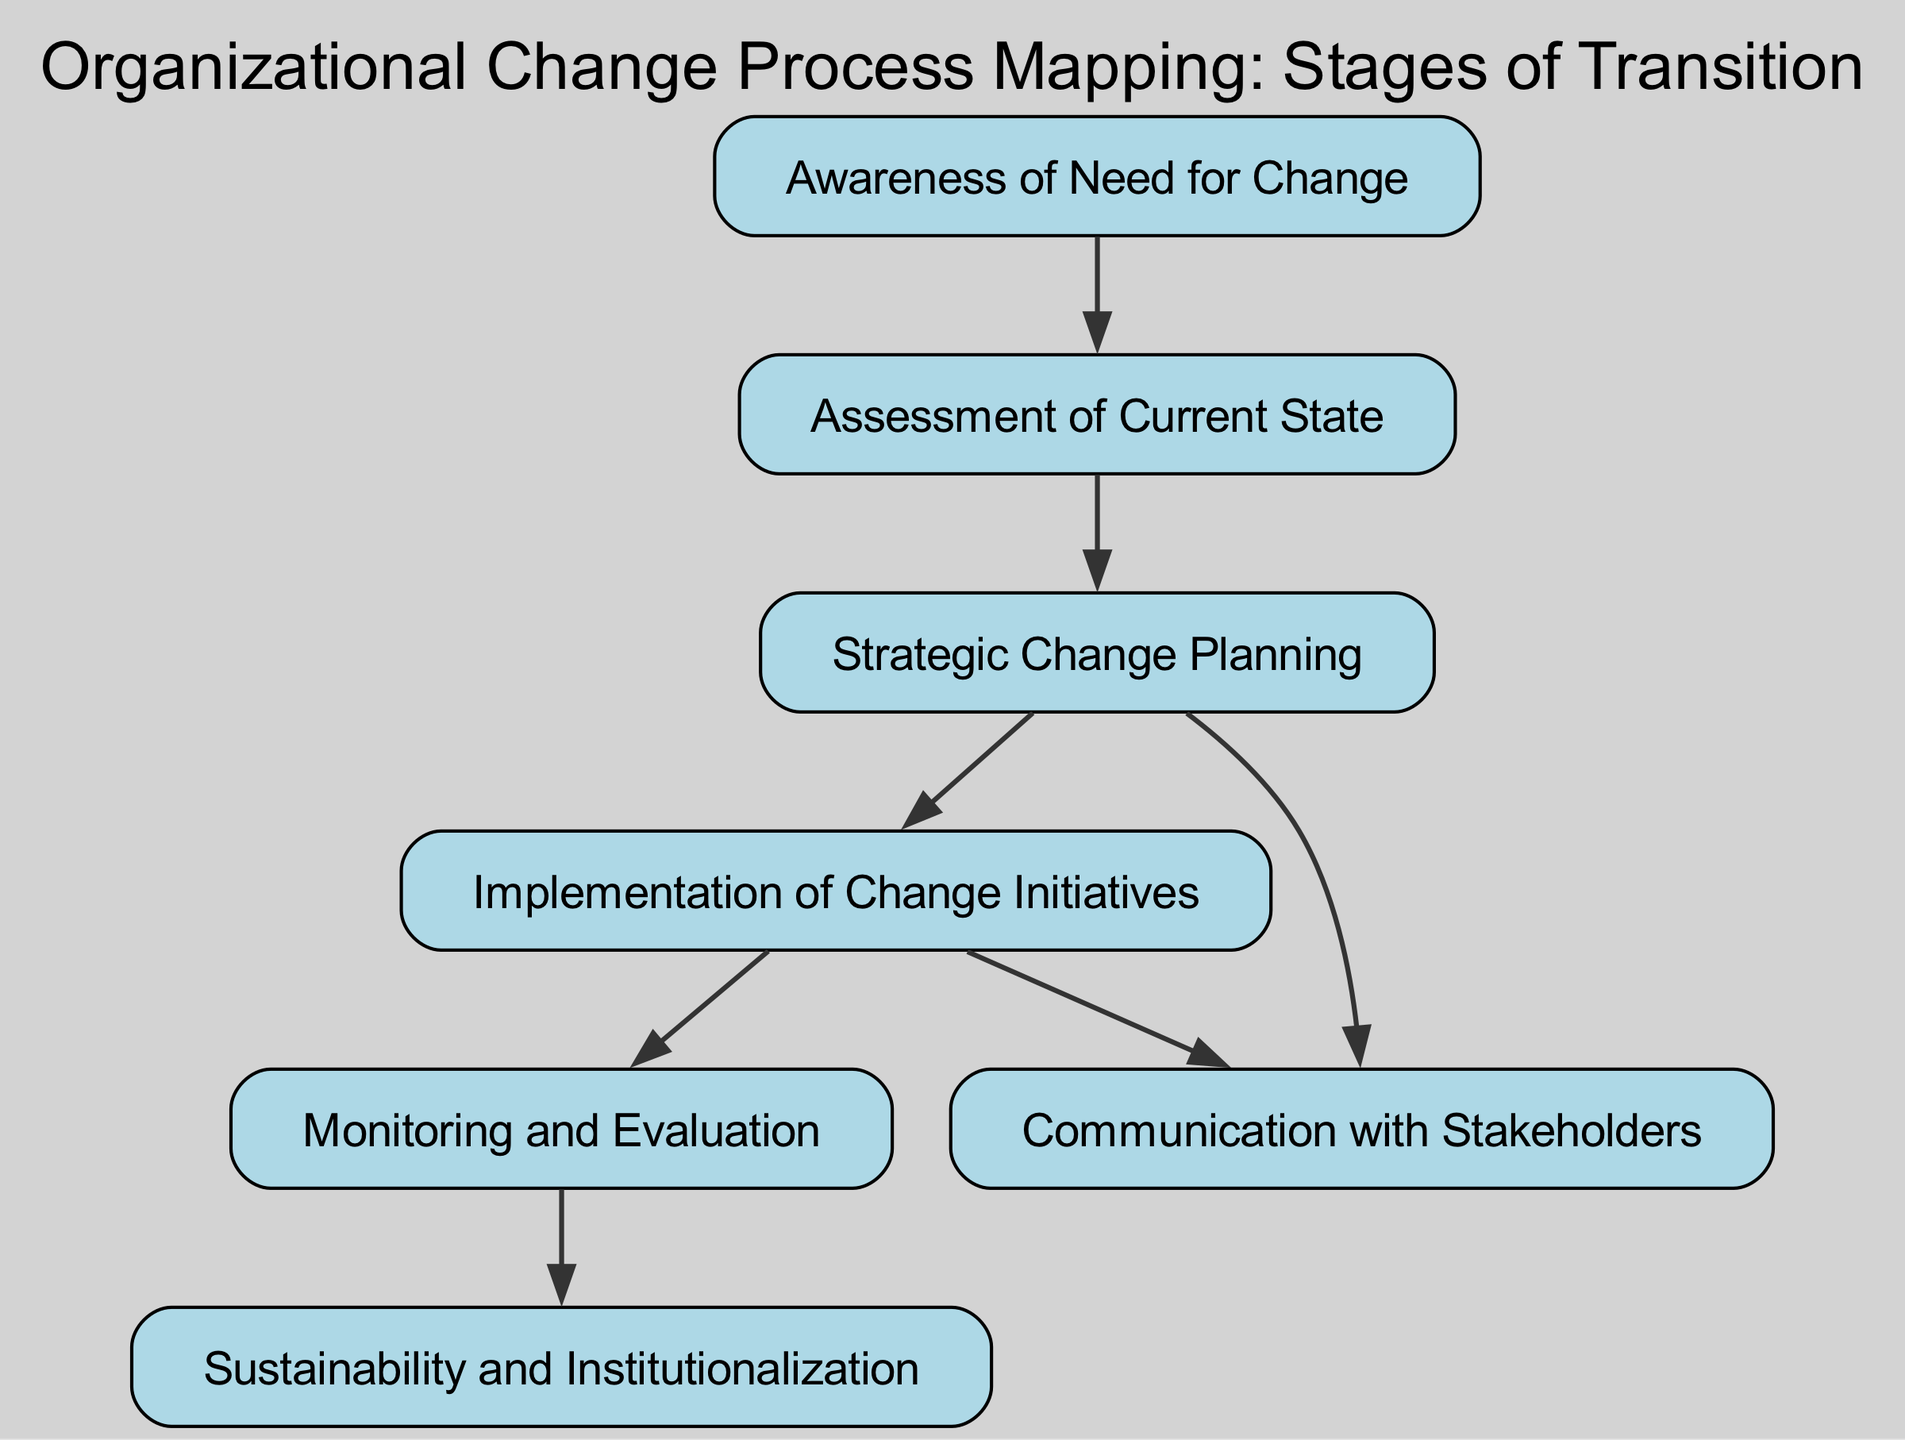What is the first stage in the organizational change process? The diagram indicates that the first stage is "Awareness of Need for Change." This is identified as the starting node in the directed graph.
Answer: Awareness of Need for Change How many total stages are represented in the diagram? Counting the nodes in the diagram, there are a total of six distinct stages listed: Awareness, Assessment, Planning, Implementation, Monitoring, and Sustainability.
Answer: Six Which stage directly follows 'Assessment'? The edge from the node "Assessment" points to "Planning," which indicates that "Planning" is the subsequent stage directly after "Assessment."
Answer: Planning What is the relationship between 'Planning' and 'Communication'? The diagram shows two edges leading from "Planning": one directly connects it to "Implementation," and another connects it to "Communication." This indicates that "Planning" is related to both "Implementation" and "Communication," showing it shares a parallel flow with "Communication."
Answer: Related What is the last step in the organizational change process? The final stage in the directed graph is "Sustainability and Institutionalization," indicated by the last node reached in the flow of the process.
Answer: Sustainability and Institutionalization Which nodes connect to 'Communication'? From the diagram, both "Planning" and "Implementation" have edges leading to "Communication," which denotes that both stages have a direct relationship with "Communication."
Answer: Planning, Implementation How many edges are present in the diagram? By counting the connections (edges) defined between the nodes, it can be seen that there are a total of seven edges in the graph.
Answer: Seven In which order do stages 'Implementation' and 'Monitoring' appear in the process? The directed flow of the diagram shows that "Implementation" leads to "Monitoring," meaning "Implementation" comes before "Monitoring" in the organizational change process.
Answer: Implementation, Monitoring 